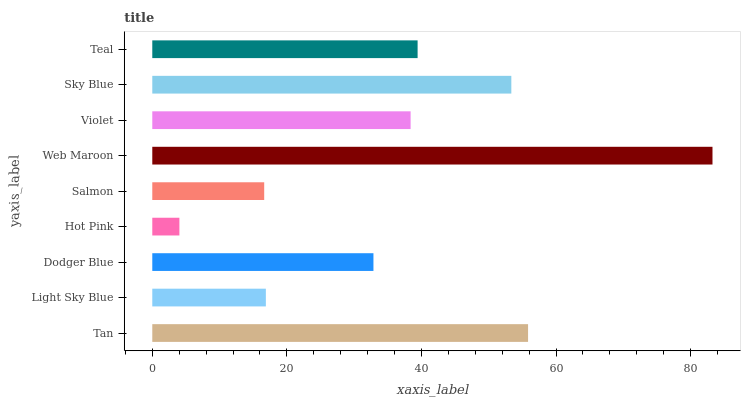Is Hot Pink the minimum?
Answer yes or no. Yes. Is Web Maroon the maximum?
Answer yes or no. Yes. Is Light Sky Blue the minimum?
Answer yes or no. No. Is Light Sky Blue the maximum?
Answer yes or no. No. Is Tan greater than Light Sky Blue?
Answer yes or no. Yes. Is Light Sky Blue less than Tan?
Answer yes or no. Yes. Is Light Sky Blue greater than Tan?
Answer yes or no. No. Is Tan less than Light Sky Blue?
Answer yes or no. No. Is Violet the high median?
Answer yes or no. Yes. Is Violet the low median?
Answer yes or no. Yes. Is Sky Blue the high median?
Answer yes or no. No. Is Dodger Blue the low median?
Answer yes or no. No. 